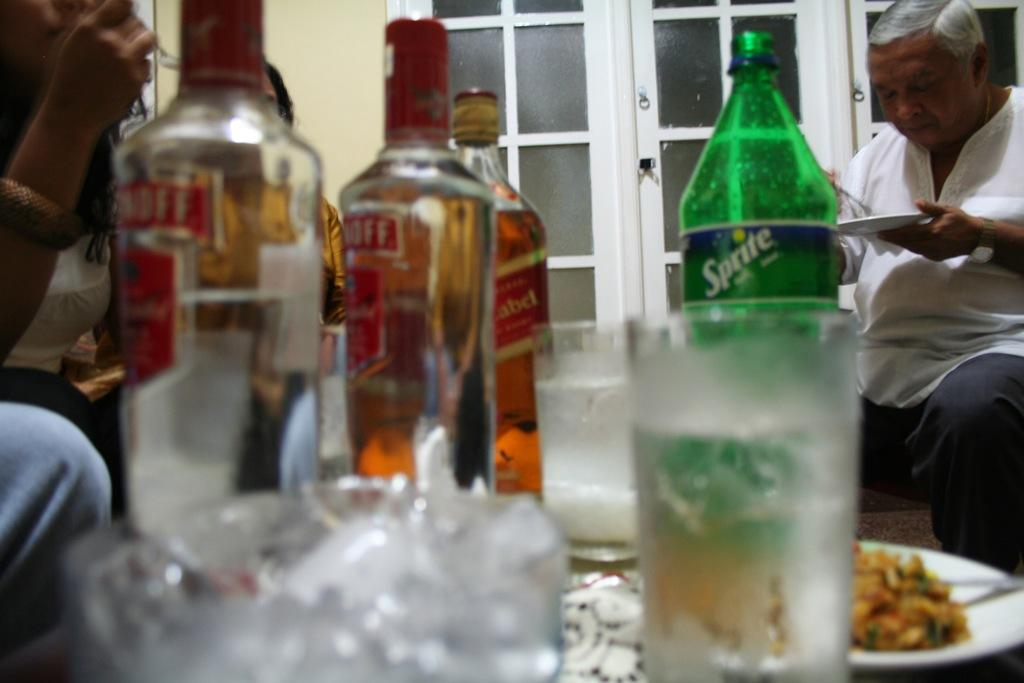Provide a one-sentence caption for the provided image. A TABLE WITH FOOD AND SEVERAL BOTTLES OF SMIRNOFFF LIQUOR BOTTLES. 